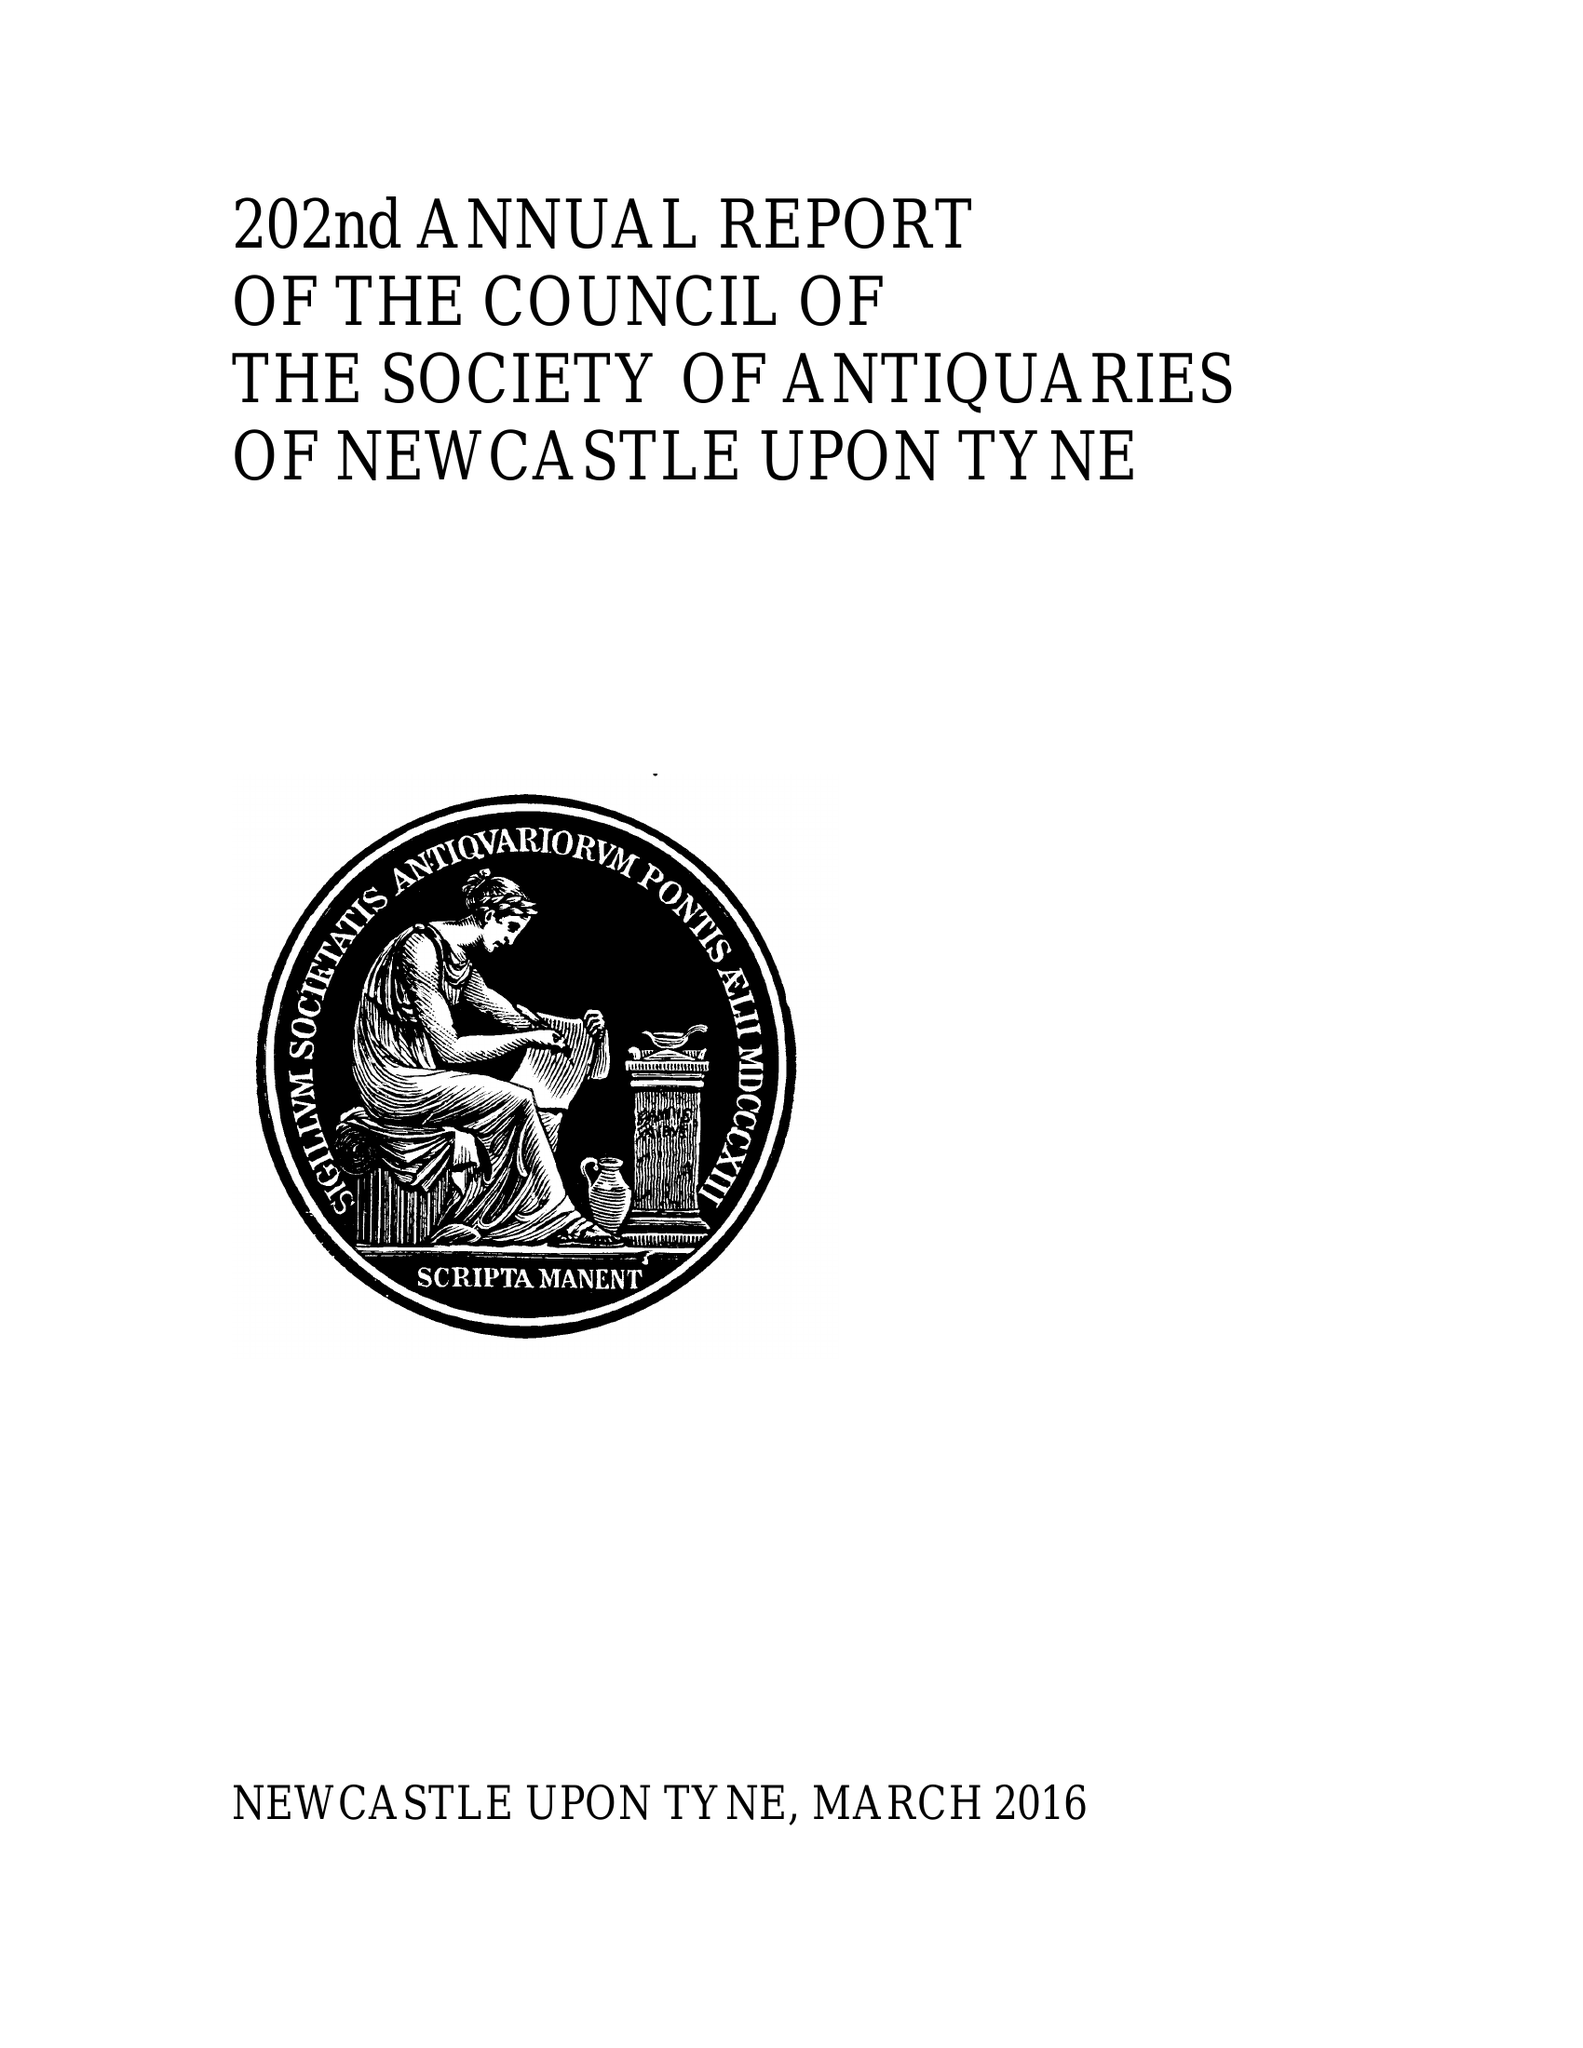What is the value for the address__street_line?
Answer the question using a single word or phrase. BARRAS BRIDGE 